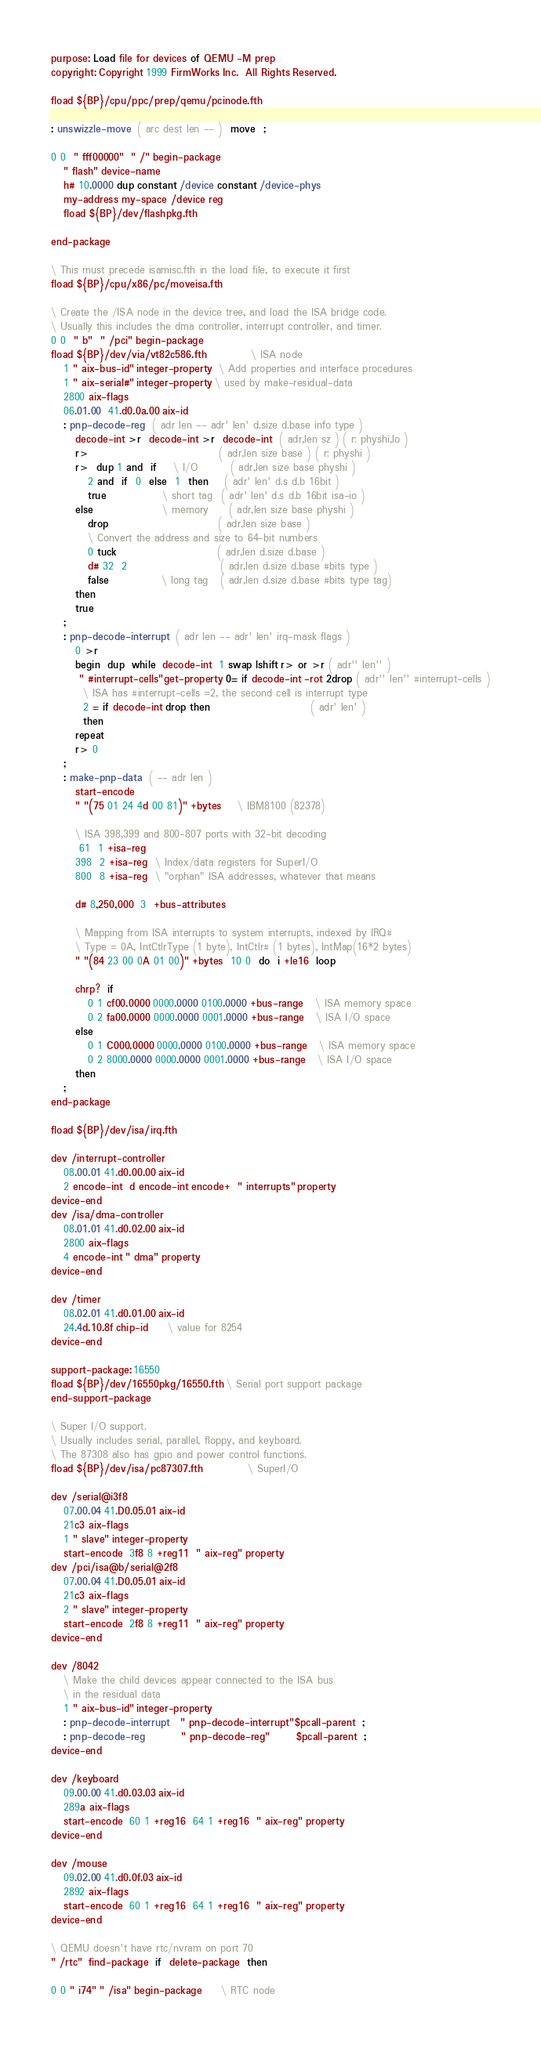<code> <loc_0><loc_0><loc_500><loc_500><_Forth_>purpose: Load file for devices of QEMU -M prep
copyright: Copyright 1999 FirmWorks Inc.  All Rights Reserved.

fload ${BP}/cpu/ppc/prep/qemu/pcinode.fth

: unswizzle-move  ( arc dest len -- )  move  ;

0 0  " fff00000"  " /" begin-package
   " flash" device-name
   h# 10.0000 dup constant /device constant /device-phys
   my-address my-space /device reg
   fload ${BP}/dev/flashpkg.fth

end-package

\ This must precede isamisc.fth in the load file, to execute it first
fload ${BP}/cpu/x86/pc/moveisa.fth

\ Create the /ISA node in the device tree, and load the ISA bridge code.
\ Usually this includes the dma controller, interrupt controller, and timer.
0 0  " b"  " /pci" begin-package
fload ${BP}/dev/via/vt82c586.fth			\ ISA node
   1 " aix-bus-id" integer-property  \ Add properties and interface procedures
   1 " aix-serial#" integer-property \ used by make-residual-data
   2800 aix-flags
   06.01.00  41.d0.0a.00 aix-id
   : pnp-decode-reg  ( adr len -- adr' len' d.size d.base info type )
      decode-int >r  decode-int >r  decode-int  ( adr,len sz ) ( r: physhi,lo )
      r>                                ( adr,len size base ) ( r: physhi )
      r>  dup 1 and  if    \ I/O        ( adr,len size base physhi )
         2 and  if  0  else  1  then    ( adr' len' d.s d.b 16bit )
         true              \ short tag  ( adr' len' d.s d.b 16bit isa-io )
      else                 \ memory     ( adr,len size base physhi )
         drop                           ( adr,len size base )
         \ Convert the address and size to 64-bit numbers
         0 tuck                         ( adr,len d.size d.base )
         d# 32  2                       ( adr,len d.size d.base #bits type )
         false             \ long tag   ( adr,len d.size d.base #bits type tag)
      then
      true
   ;
   : pnp-decode-interrupt  ( adr len -- adr' len' irq-mask flags )
      0 >r
      begin  dup  while  decode-int  1 swap lshift r> or >r ( adr'' len'' )
       " #interrupt-cells" get-property 0= if decode-int -rot 2drop ( adr'' len'' #interrupt-cells )
        \ ISA has #interrupt-cells =2, the second cell is interrupt type
        2 = if decode-int drop then                         ( adr' len' )
        then
      repeat
      r> 0
   ;
   : make-pnp-data  ( -- adr len )
      start-encode
      " "(75 01 24 4d 00 81)" +bytes    \ IBM8100 (82378)

      \ ISA 398,399 and 800-807 ports with 32-bit decoding
       61  1 +isa-reg
      398  2 +isa-reg  \ Index/data registers for SuperI/O
      800  8 +isa-reg  \ "orphan" ISA addresses, whatever that means

      d# 8,250,000  3  +bus-attributes

      \ Mapping from ISA interrupts to system interrupts, indexed by IRQ#
      \ Type = 0A, IntCtlrType (1 byte), IntCtlr# (1 bytes), IntMap(16*2 bytes)
      " "(84 23 00 0A 01 00)" +bytes  10 0  do  i +le16  loop

      chrp?  if
         0 1 cf00.0000 0000.0000 0100.0000 +bus-range   \ ISA memory space
         0 2 fa00.0000 0000.0000 0001.0000 +bus-range   \ ISA I/O space
      else
         0 1 C000.0000 0000.0000 0100.0000 +bus-range   \ ISA memory space
         0 2 8000.0000 0000.0000 0001.0000 +bus-range   \ ISA I/O space
      then
   ;
end-package

fload ${BP}/dev/isa/irq.fth

dev /interrupt-controller
   08.00.01 41.d0.00.00 aix-id
   2 encode-int  d encode-int encode+  " interrupts" property
device-end
dev /isa/dma-controller
   08.01.01 41.d0.02.00 aix-id
   2800 aix-flags
   4 encode-int " dma" property
device-end

dev /timer
   08.02.01 41.d0.01.00 aix-id
   24.4d.10.8f chip-id     \ value for 8254
device-end

support-package: 16550
fload ${BP}/dev/16550pkg/16550.fth  \ Serial port support package
end-support-package

\ Super I/O support.
\ Usually includes serial, parallel, floppy, and keyboard.
\ The 87308 also has gpio and power control functions.
fload ${BP}/dev/isa/pc87307.fth			\ SuperI/O

dev /serial@i3f8
   07.00.04 41.D0.05.01 aix-id
   21c3 aix-flags
   1 " slave" integer-property
   start-encode  3f8 8 +reg11  " aix-reg" property
dev /pci/isa@b/serial@2f8
   07.00.04 41.D0.05.01 aix-id
   21c3 aix-flags
   2 " slave" integer-property
   start-encode  2f8 8 +reg11  " aix-reg" property
device-end

dev /8042
   \ Make the child devices appear connected to the ISA bus
   \ in the residual data
   1 " aix-bus-id" integer-property
   : pnp-decode-interrupt   " pnp-decode-interrupt" $pcall-parent  ;
   : pnp-decode-reg         " pnp-decode-reg"       $pcall-parent  ;
device-end

dev /keyboard
   09.00.00 41.d0.03.03 aix-id
   289a aix-flags
   start-encode  60 1 +reg16  64 1 +reg16  " aix-reg" property
device-end

dev /mouse
   09.02.00 41.d0.0f.03 aix-id
   2892 aix-flags
   start-encode  60 1 +reg16  64 1 +reg16  " aix-reg" property
device-end

\ QEMU doesn't have rtc/nvram on port 70
" /rtc"  find-package  if  delete-package  then

0 0 " i74" " /isa" begin-package	 \ RTC node</code> 